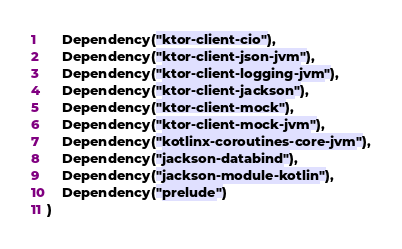<code> <loc_0><loc_0><loc_500><loc_500><_Kotlin_>    Dependency("ktor-client-cio"),
    Dependency("ktor-client-json-jvm"),
    Dependency("ktor-client-logging-jvm"),
    Dependency("ktor-client-jackson"),
    Dependency("ktor-client-mock"),
    Dependency("ktor-client-mock-jvm"),
    Dependency("kotlinx-coroutines-core-jvm"),
    Dependency("jackson-databind"),
    Dependency("jackson-module-kotlin"),
    Dependency("prelude")
)</code> 